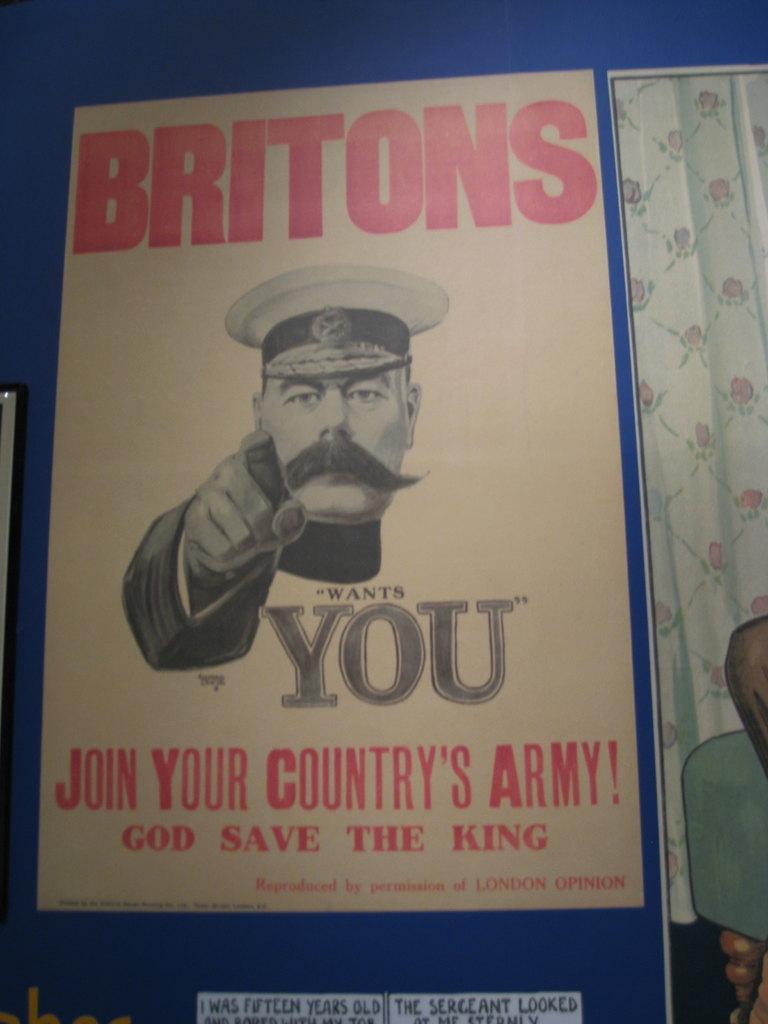Describe this image in one or two sentences. In this image we can see a poster with a picture and text written on it. 